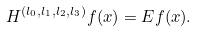Convert formula to latex. <formula><loc_0><loc_0><loc_500><loc_500>H ^ { ( l _ { 0 } , l _ { 1 } , l _ { 2 } , l _ { 3 } ) } f ( x ) = E f ( x ) .</formula> 